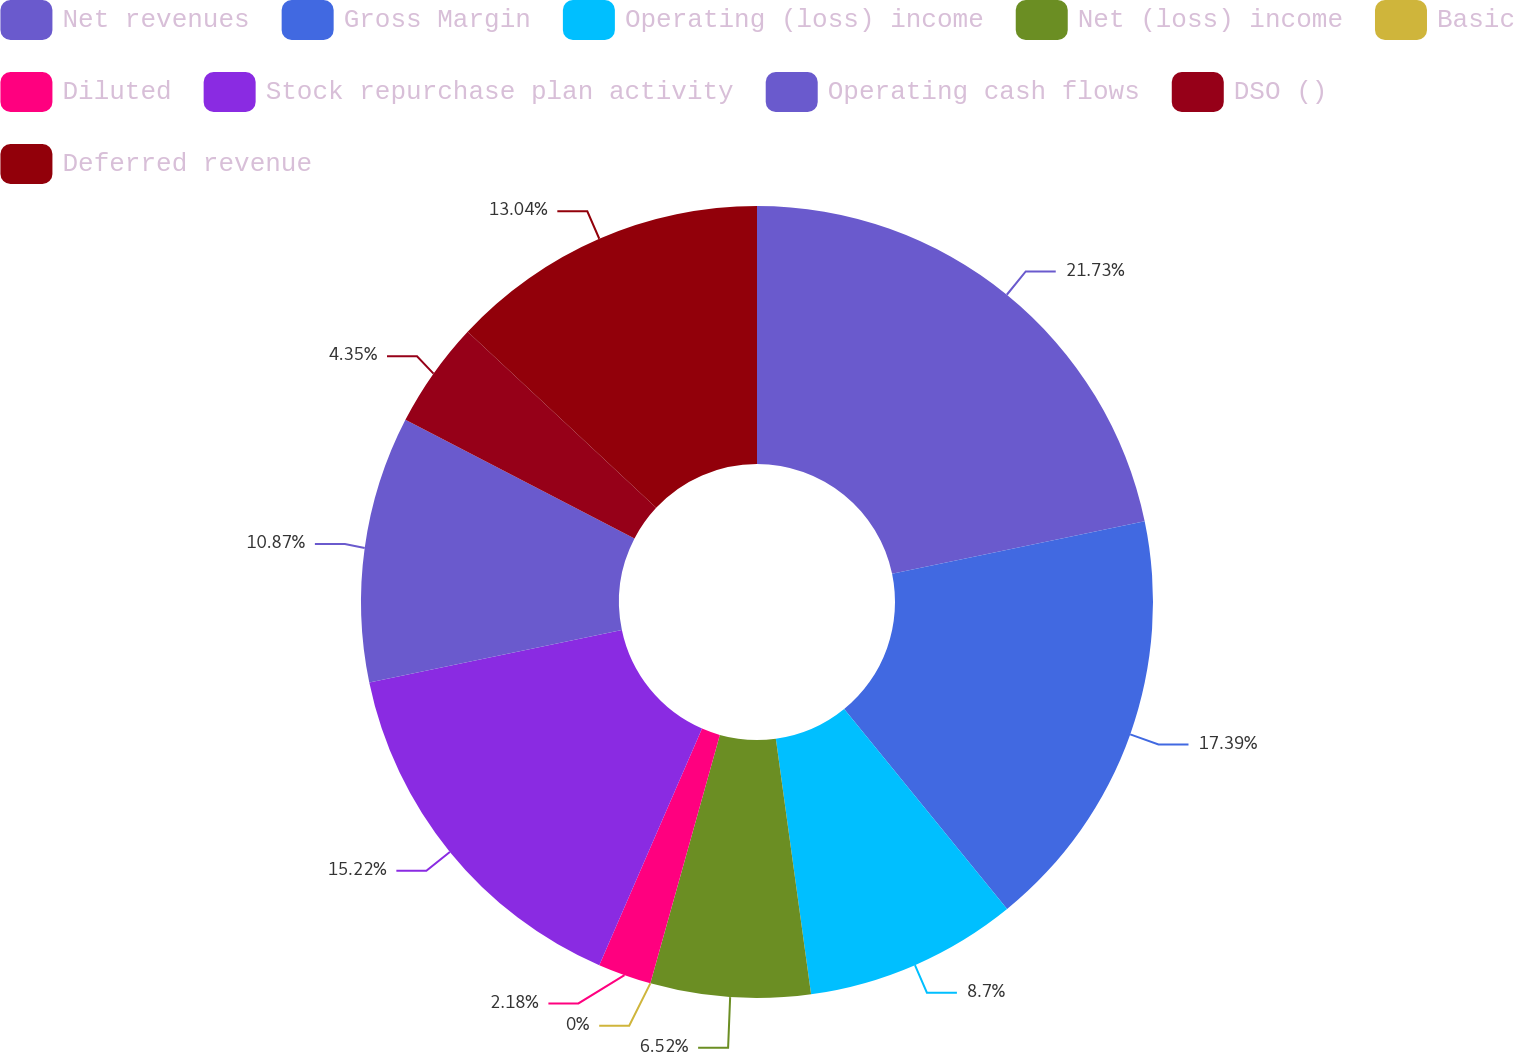<chart> <loc_0><loc_0><loc_500><loc_500><pie_chart><fcel>Net revenues<fcel>Gross Margin<fcel>Operating (loss) income<fcel>Net (loss) income<fcel>Basic<fcel>Diluted<fcel>Stock repurchase plan activity<fcel>Operating cash flows<fcel>DSO ()<fcel>Deferred revenue<nl><fcel>21.73%<fcel>17.39%<fcel>8.7%<fcel>6.52%<fcel>0.0%<fcel>2.18%<fcel>15.22%<fcel>10.87%<fcel>4.35%<fcel>13.04%<nl></chart> 